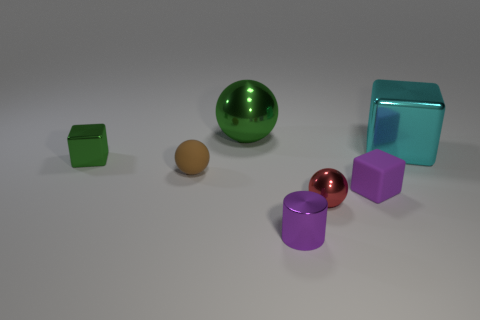There is a big thing that is on the right side of the purple block; is it the same color as the tiny matte cube?
Your answer should be compact. No. There is a red thing that is the same size as the green block; what shape is it?
Give a very brief answer. Sphere. What number of other things are the same color as the small cylinder?
Your response must be concise. 1. What number of other things are there of the same material as the green ball
Your answer should be very brief. 4. There is a matte ball; does it have the same size as the green metallic object in front of the large cyan object?
Ensure brevity in your answer.  Yes. What is the color of the large sphere?
Provide a short and direct response. Green. There is a green shiny object left of the green thing that is right of the small thing that is to the left of the small brown object; what is its shape?
Your answer should be compact. Cube. What is the material of the ball behind the thing to the left of the tiny brown ball?
Give a very brief answer. Metal. There is a small object that is made of the same material as the purple cube; what shape is it?
Your answer should be very brief. Sphere. Are there any other things that have the same shape as the big green shiny object?
Provide a short and direct response. Yes. 